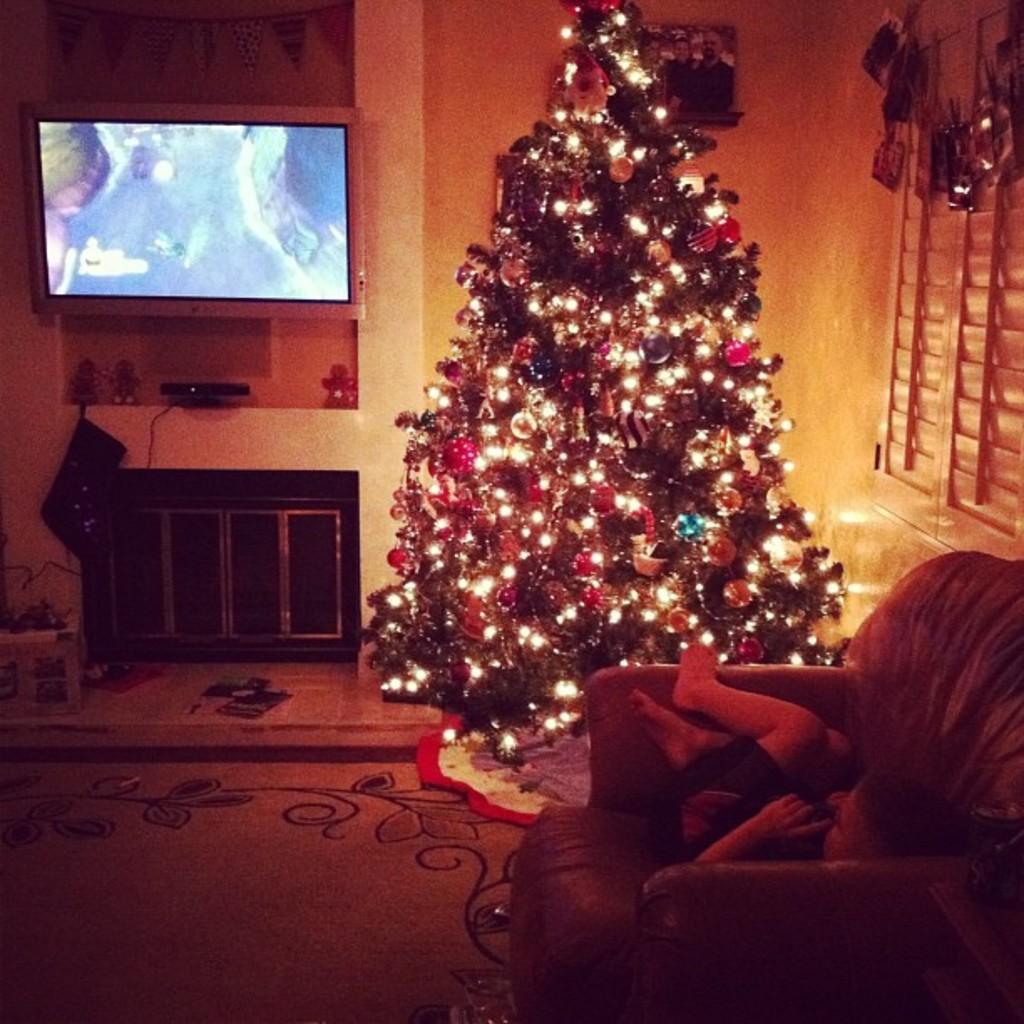Could you give a brief overview of what you see in this image? In the center of the image we can see Christmas tree and lights. On the right side of the image we can see a boy in the chair. In the background we can see television, cupboards, set top box, windows, photo frame and wall. 